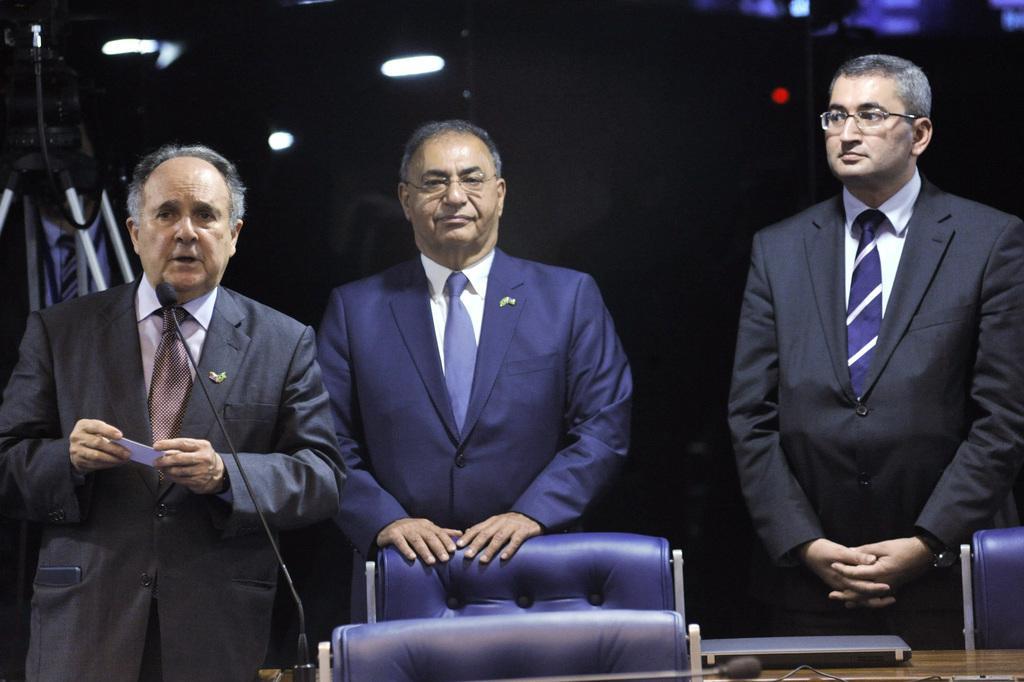Can you describe this image briefly? In this picture we can see three men wore blazers, ties and in front of them we can see a laptop, mics and in the background we can see lights and it is dark. 